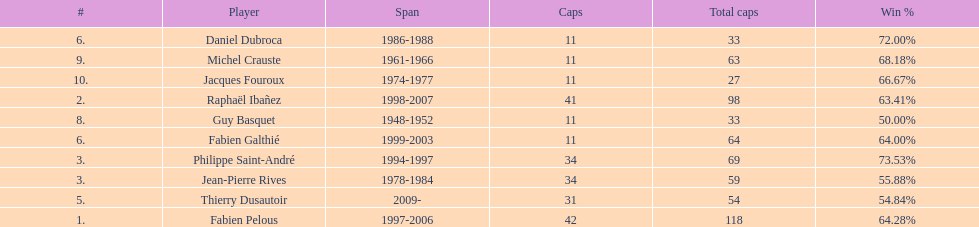How long did fabien pelous serve as captain in the french national rugby team? 9 years. 